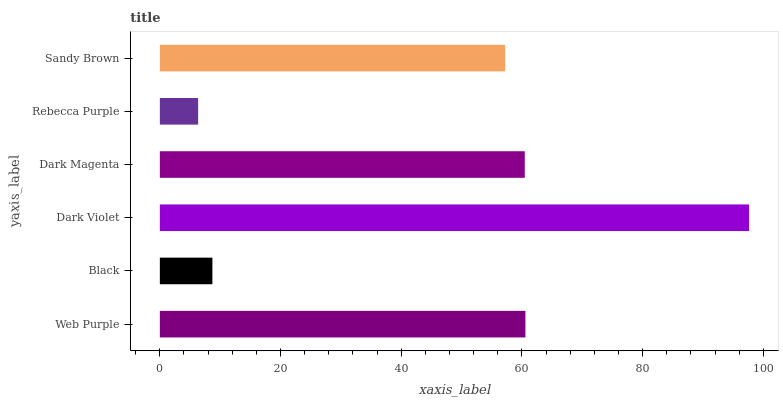Is Rebecca Purple the minimum?
Answer yes or no. Yes. Is Dark Violet the maximum?
Answer yes or no. Yes. Is Black the minimum?
Answer yes or no. No. Is Black the maximum?
Answer yes or no. No. Is Web Purple greater than Black?
Answer yes or no. Yes. Is Black less than Web Purple?
Answer yes or no. Yes. Is Black greater than Web Purple?
Answer yes or no. No. Is Web Purple less than Black?
Answer yes or no. No. Is Dark Magenta the high median?
Answer yes or no. Yes. Is Sandy Brown the low median?
Answer yes or no. Yes. Is Dark Violet the high median?
Answer yes or no. No. Is Dark Violet the low median?
Answer yes or no. No. 